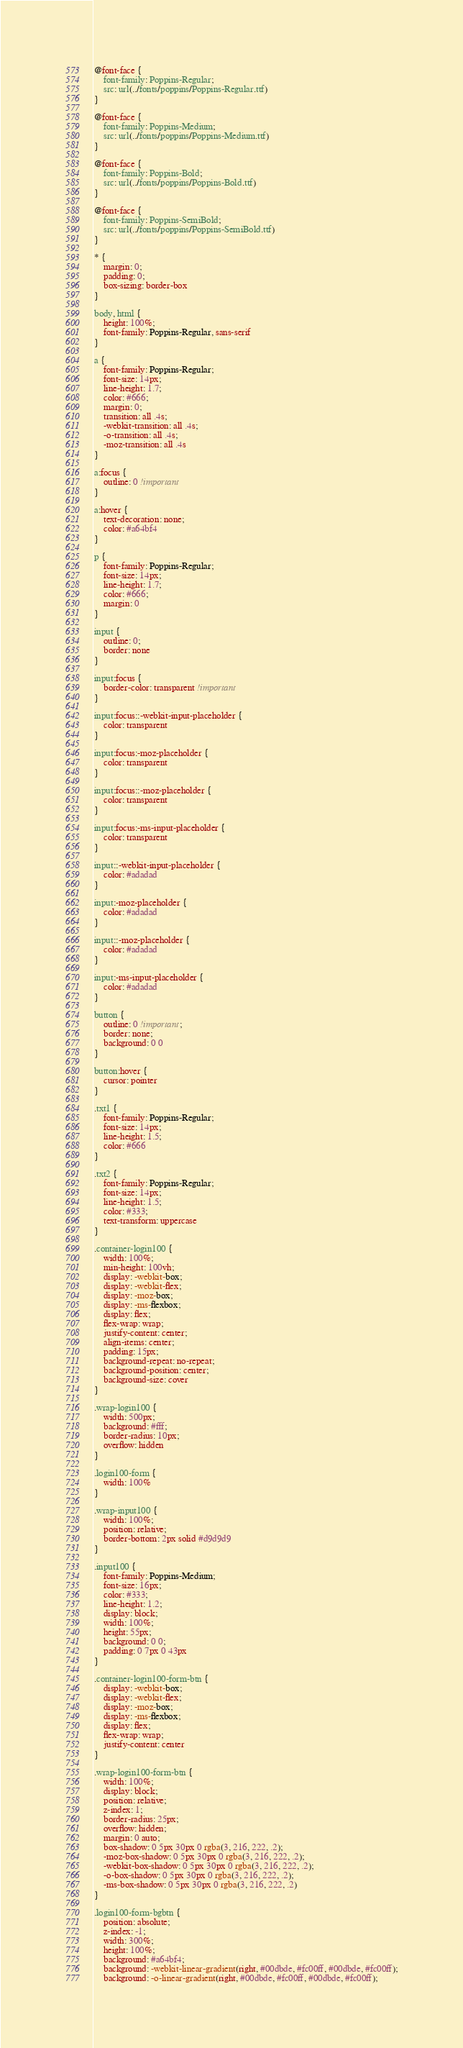Convert code to text. <code><loc_0><loc_0><loc_500><loc_500><_CSS_>@font-face {
    font-family: Poppins-Regular;
    src: url(../fonts/poppins/Poppins-Regular.ttf)
}

@font-face {
    font-family: Poppins-Medium;
    src: url(../fonts/poppins/Poppins-Medium.ttf)
}

@font-face {
    font-family: Poppins-Bold;
    src: url(../fonts/poppins/Poppins-Bold.ttf)
}

@font-face {
    font-family: Poppins-SemiBold;
    src: url(../fonts/poppins/Poppins-SemiBold.ttf)
}

* {
    margin: 0;
    padding: 0;
    box-sizing: border-box
}

body, html {
    height: 100%;
    font-family: Poppins-Regular, sans-serif
}

a {
    font-family: Poppins-Regular;
    font-size: 14px;
    line-height: 1.7;
    color: #666;
    margin: 0;
    transition: all .4s;
    -webkit-transition: all .4s;
    -o-transition: all .4s;
    -moz-transition: all .4s
}

a:focus {
    outline: 0 !important
}

a:hover {
    text-decoration: none;
    color: #a64bf4
}

p {
    font-family: Poppins-Regular;
    font-size: 14px;
    line-height: 1.7;
    color: #666;
    margin: 0
}

input {
    outline: 0;
    border: none
}

input:focus {
    border-color: transparent !important
}

input:focus::-webkit-input-placeholder {
    color: transparent
}

input:focus:-moz-placeholder {
    color: transparent
}

input:focus::-moz-placeholder {
    color: transparent
}

input:focus:-ms-input-placeholder {
    color: transparent
}

input::-webkit-input-placeholder {
    color: #adadad
}

input:-moz-placeholder {
    color: #adadad
}

input::-moz-placeholder {
    color: #adadad
}

input:-ms-input-placeholder {
    color: #adadad
}

button {
    outline: 0 !important;
    border: none;
    background: 0 0
}

button:hover {
    cursor: pointer
}

.txt1 {
    font-family: Poppins-Regular;
    font-size: 14px;
    line-height: 1.5;
    color: #666
}

.txt2 {
    font-family: Poppins-Regular;
    font-size: 14px;
    line-height: 1.5;
    color: #333;
    text-transform: uppercase
}

.container-login100 {
    width: 100%;
    min-height: 100vh;
    display: -webkit-box;
    display: -webkit-flex;
    display: -moz-box;
    display: -ms-flexbox;
    display: flex;
    flex-wrap: wrap;
    justify-content: center;
    align-items: center;
    padding: 15px;
    background-repeat: no-repeat;
    background-position: center;
    background-size: cover
}

.wrap-login100 {
    width: 500px;
    background: #fff;
    border-radius: 10px;
    overflow: hidden
}

.login100-form {
    width: 100%
}

.wrap-input100 {
    width: 100%;
    position: relative;
    border-bottom: 2px solid #d9d9d9
}

.input100 {
    font-family: Poppins-Medium;
    font-size: 16px;
    color: #333;
    line-height: 1.2;
    display: block;
    width: 100%;
    height: 55px;
    background: 0 0;
    padding: 0 7px 0 43px
}

.container-login100-form-btn {
    display: -webkit-box;
    display: -webkit-flex;
    display: -moz-box;
    display: -ms-flexbox;
    display: flex;
    flex-wrap: wrap;
    justify-content: center
}

.wrap-login100-form-btn {
    width: 100%;
    display: block;
    position: relative;
    z-index: 1;
    border-radius: 25px;
    overflow: hidden;
    margin: 0 auto;
    box-shadow: 0 5px 30px 0 rgba(3, 216, 222, .2);
    -moz-box-shadow: 0 5px 30px 0 rgba(3, 216, 222, .2);
    -webkit-box-shadow: 0 5px 30px 0 rgba(3, 216, 222, .2);
    -o-box-shadow: 0 5px 30px 0 rgba(3, 216, 222, .2);
    -ms-box-shadow: 0 5px 30px 0 rgba(3, 216, 222, .2)
}

.login100-form-bgbtn {
    position: absolute;
    z-index: -1;
    width: 300%;
    height: 100%;
    background: #a64bf4;
    background: -webkit-linear-gradient(right, #00dbde, #fc00ff, #00dbde, #fc00ff);
    background: -o-linear-gradient(right, #00dbde, #fc00ff, #00dbde, #fc00ff);</code> 